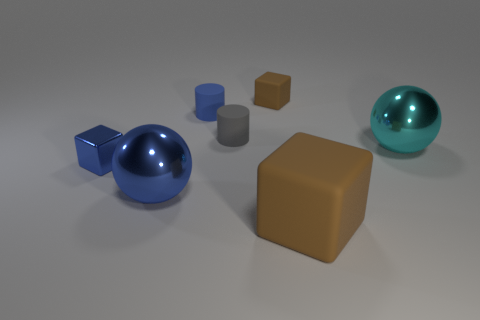Subtract all purple cylinders. How many brown cubes are left? 2 Add 2 tiny gray shiny things. How many objects exist? 9 Subtract all cylinders. How many objects are left? 5 Subtract all blue matte cylinders. Subtract all tiny gray objects. How many objects are left? 5 Add 6 big blue objects. How many big blue objects are left? 7 Add 6 big rubber objects. How many big rubber objects exist? 7 Subtract 0 purple cylinders. How many objects are left? 7 